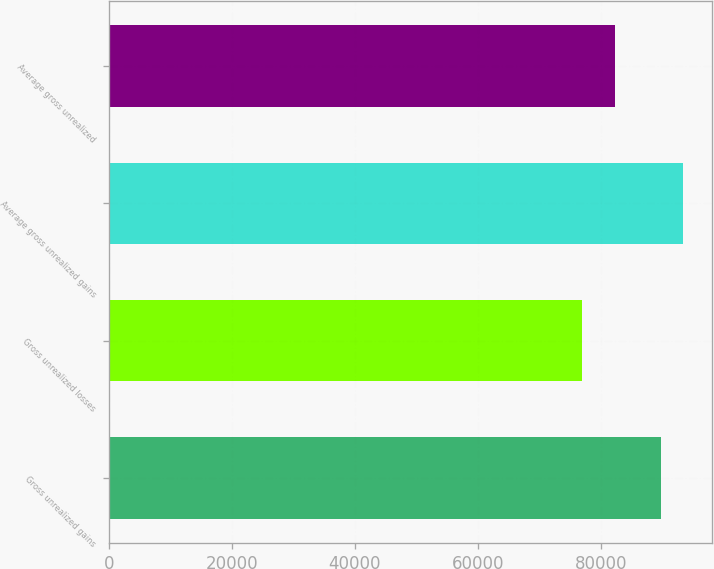Convert chart to OTSL. <chart><loc_0><loc_0><loc_500><loc_500><bar_chart><fcel>Gross unrealized gains<fcel>Gross unrealized losses<fcel>Average gross unrealized gains<fcel>Average gross unrealized<nl><fcel>89810<fcel>76896<fcel>93465<fcel>82389<nl></chart> 